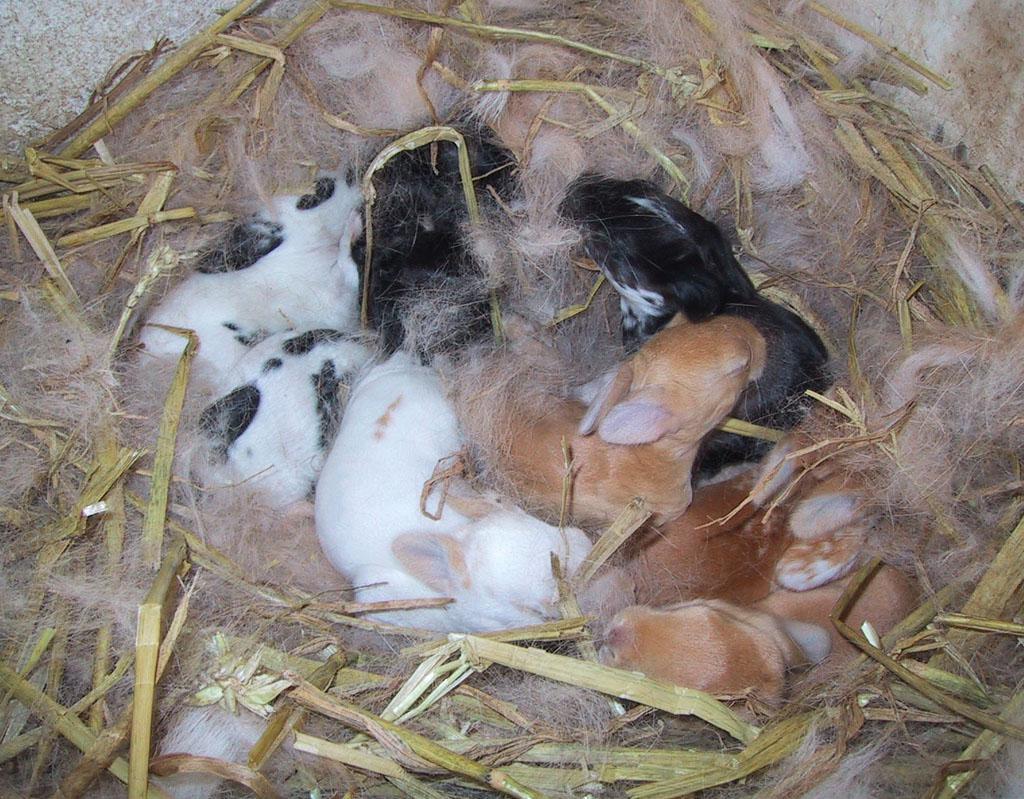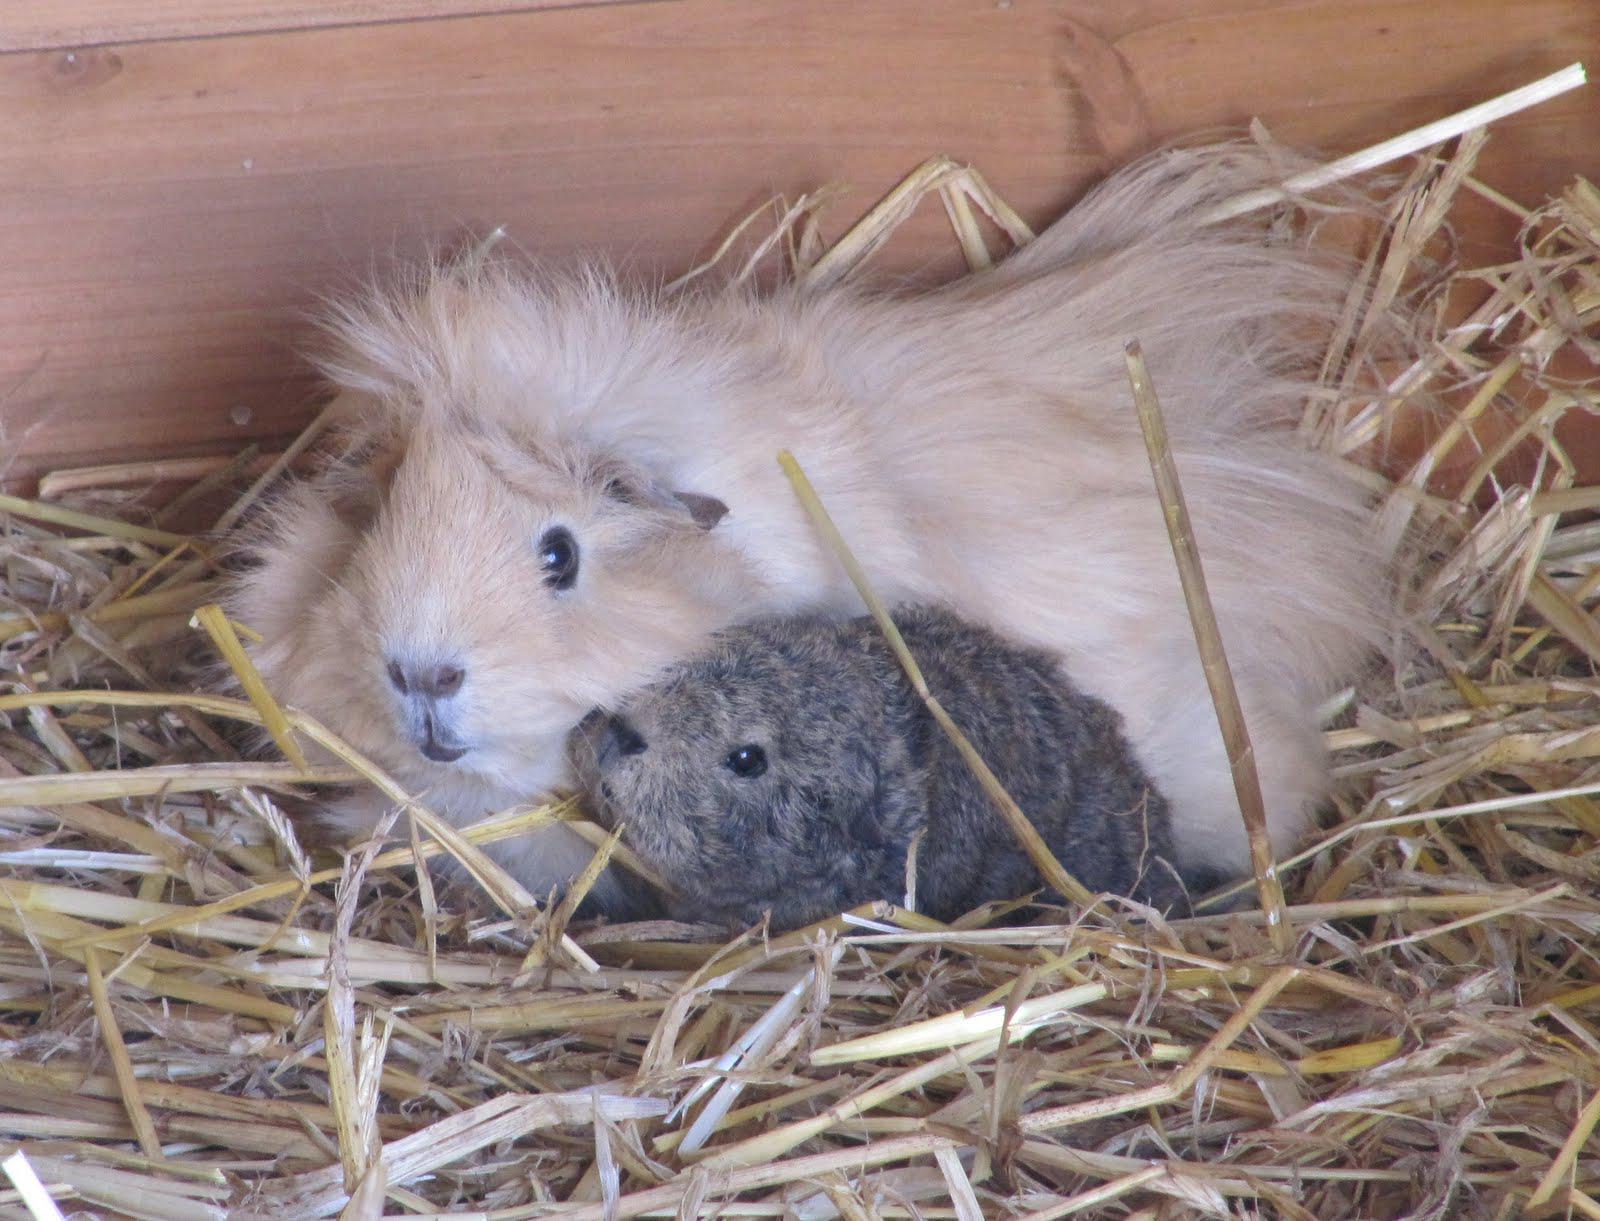The first image is the image on the left, the second image is the image on the right. Analyze the images presented: Is the assertion "there are guinea pigs on straw hay in a wooden pen" valid? Answer yes or no. Yes. 